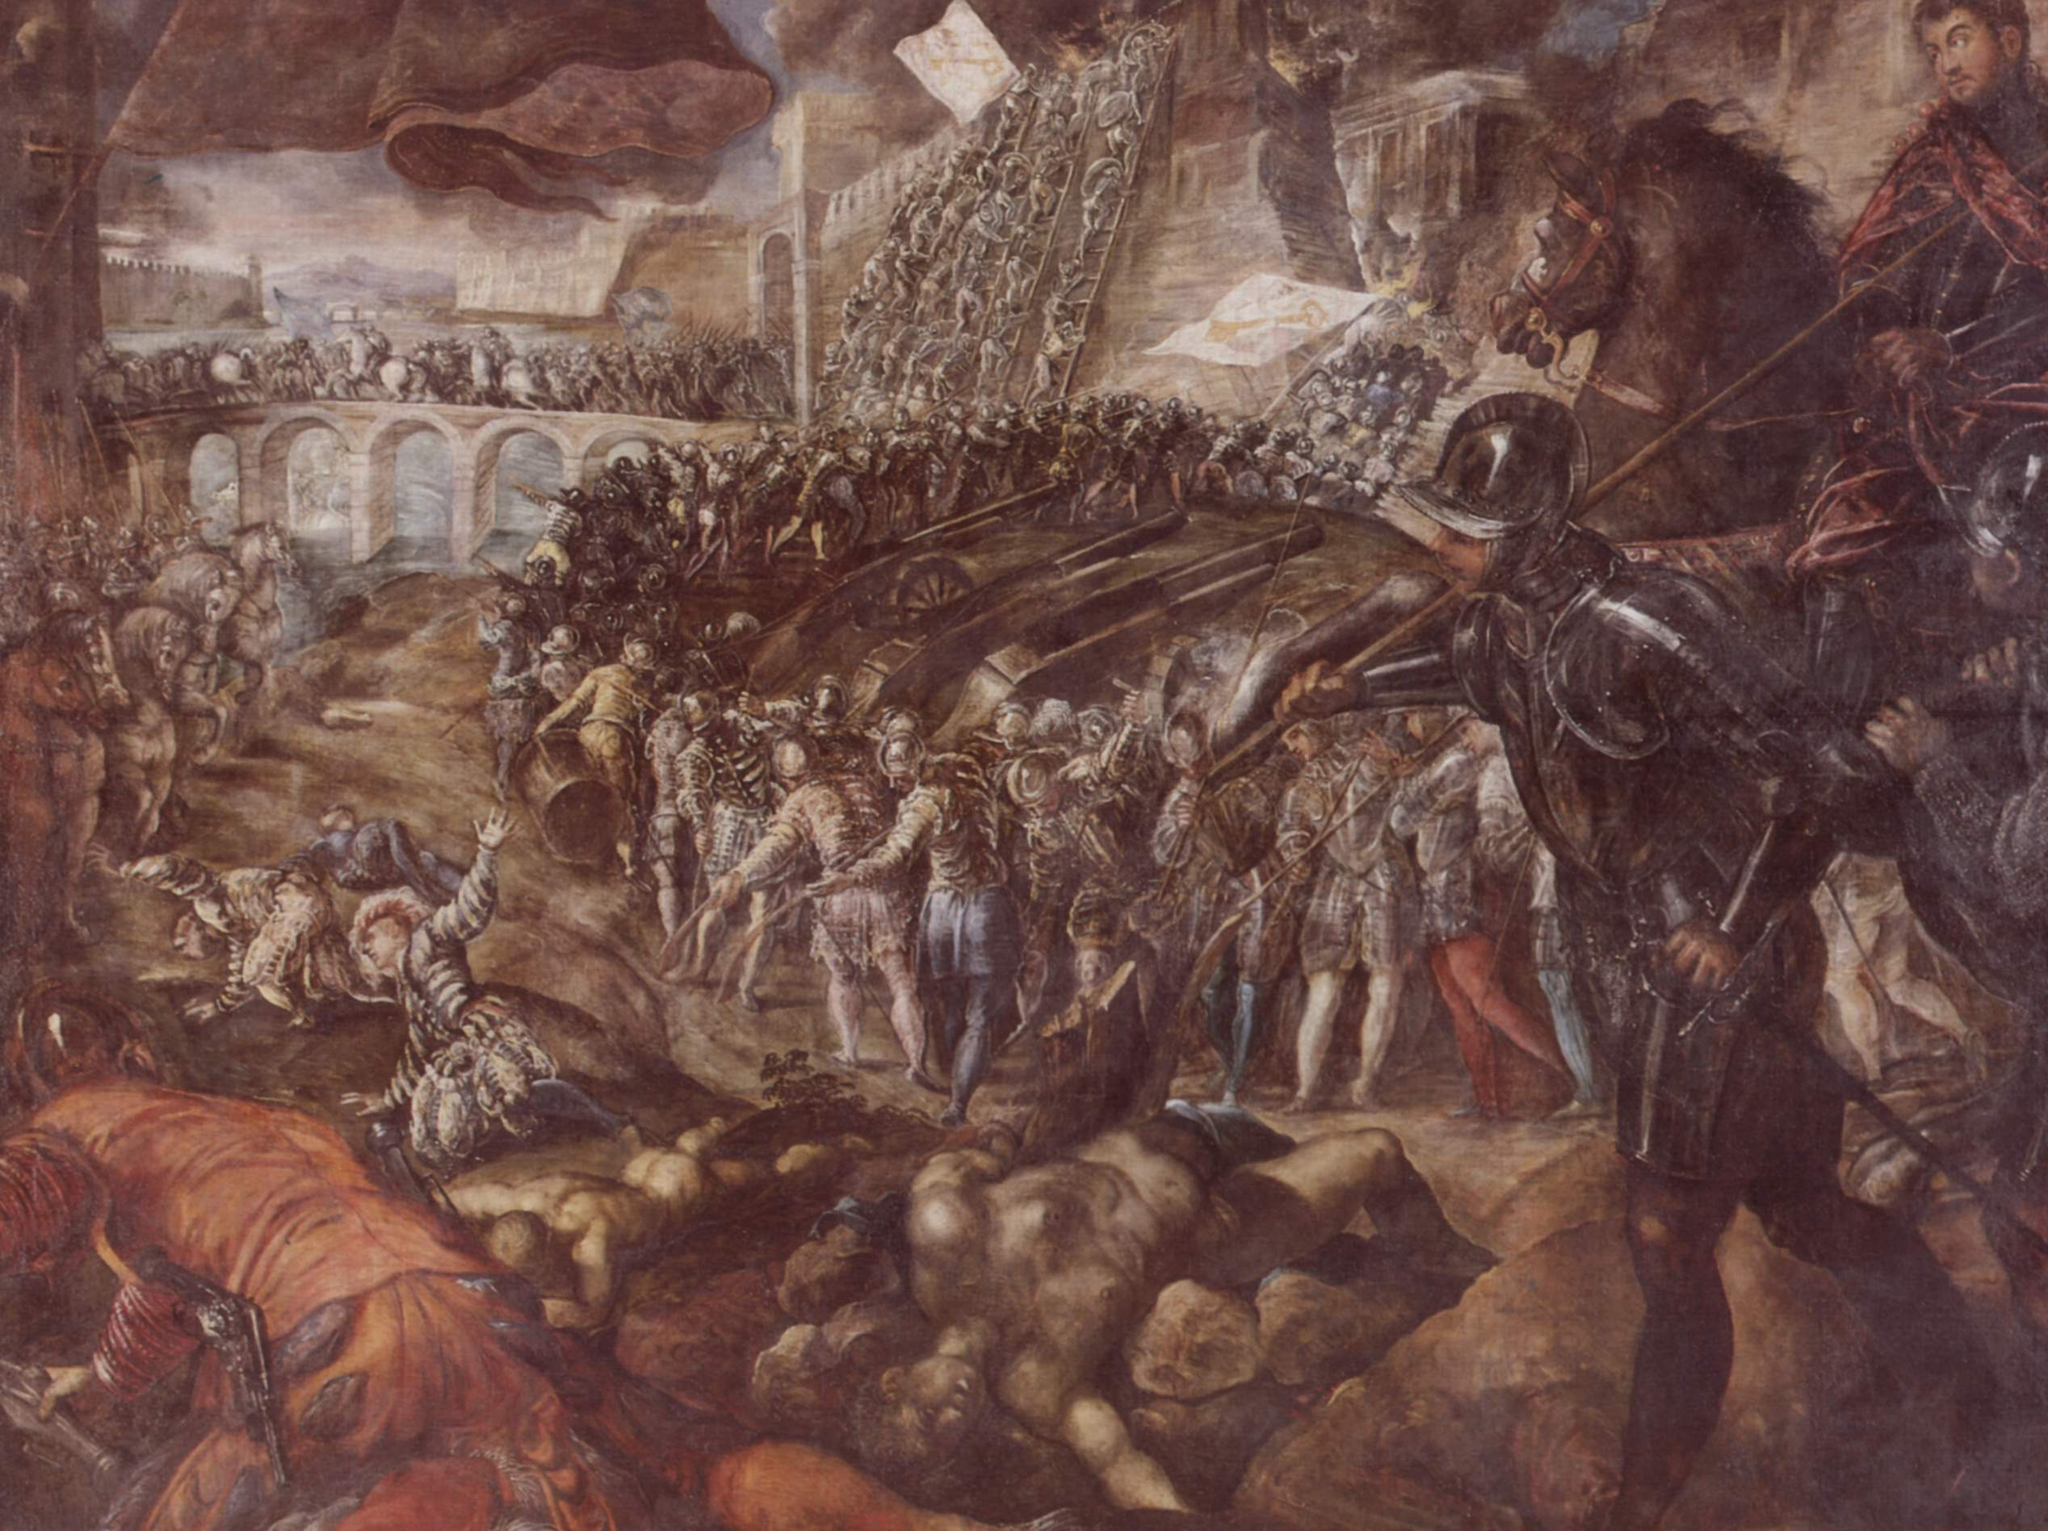Imagine and describe a story for one of the characters in the battle scene. Amidst the chaos of the battle, a knight in shining armor catches the eye—a young warrior named Sir Alaric. Born into a noble family, Alaric trained from a young age in the arts of warfare. This battle is his first major engagement, a proving ground for his courage and skill. As the conflict rages around him, Alaric charges into the fray, his heart pounding with a mix of fear and determination. He fights valiantly, defending his fellow soldiers and engaging in fierce duels with enemy knights. The battle tests his limits, both physically and mentally, but Alaric's resolve remains unbroken. His bravery and leadership earn him recognition from his superiors, and by the end of the day, Sir Alaric is heralded as a rising star, destined for greatness in the annals of history. What might be the thoughts going through Sir Alaric's mind during this battle? As Sir Alaric weaves through the battlefield, his mind races with myriad thoughts. He grapples with the stark reality of the violence around him, a contrast to the idealized visions of glory he had as a child. He wonders about the fate of his family and home, hoping his bravery safeguards their future. Amidst the clang of steel and cries of combat, he thinks about his fallen comrades, their sacrifices fueling his determination. The weight of responsibility and the desire to prove himself push him forward, each swing of his sword a testament to his will to survive and protect. Despite the chaos, a single thought lingers—if he survives today, he will be forever changed, forging a path defined by this baptism of fire. 